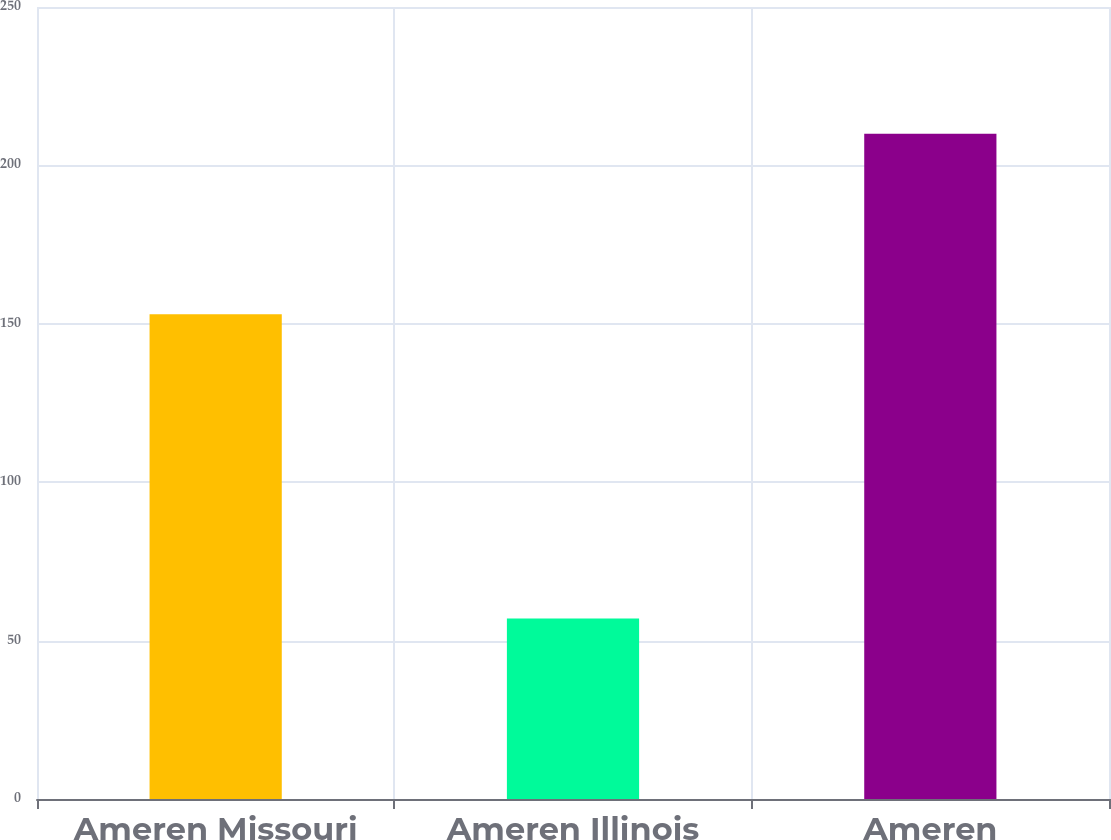Convert chart to OTSL. <chart><loc_0><loc_0><loc_500><loc_500><bar_chart><fcel>Ameren Missouri<fcel>Ameren Illinois<fcel>Ameren<nl><fcel>153<fcel>57<fcel>210<nl></chart> 